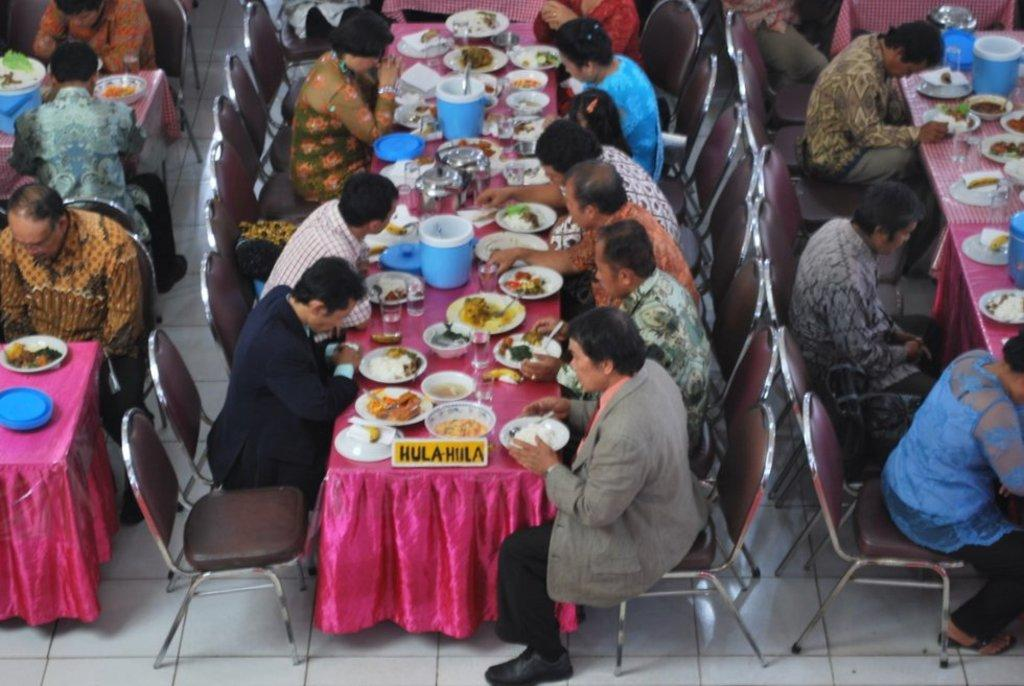How many people are in the image? There is a group of people in the image. What are the people doing in the image? The people are sitting on chairs. What is the arrangement of the chairs in the image? The chairs are arranged around a dining table. What can be found on the dining table? There are plates, bowls, and boxes with food items on the dining table. What type of roof can be seen above the people in the image? There is no roof visible in the image; it appears to be an outdoor setting. 